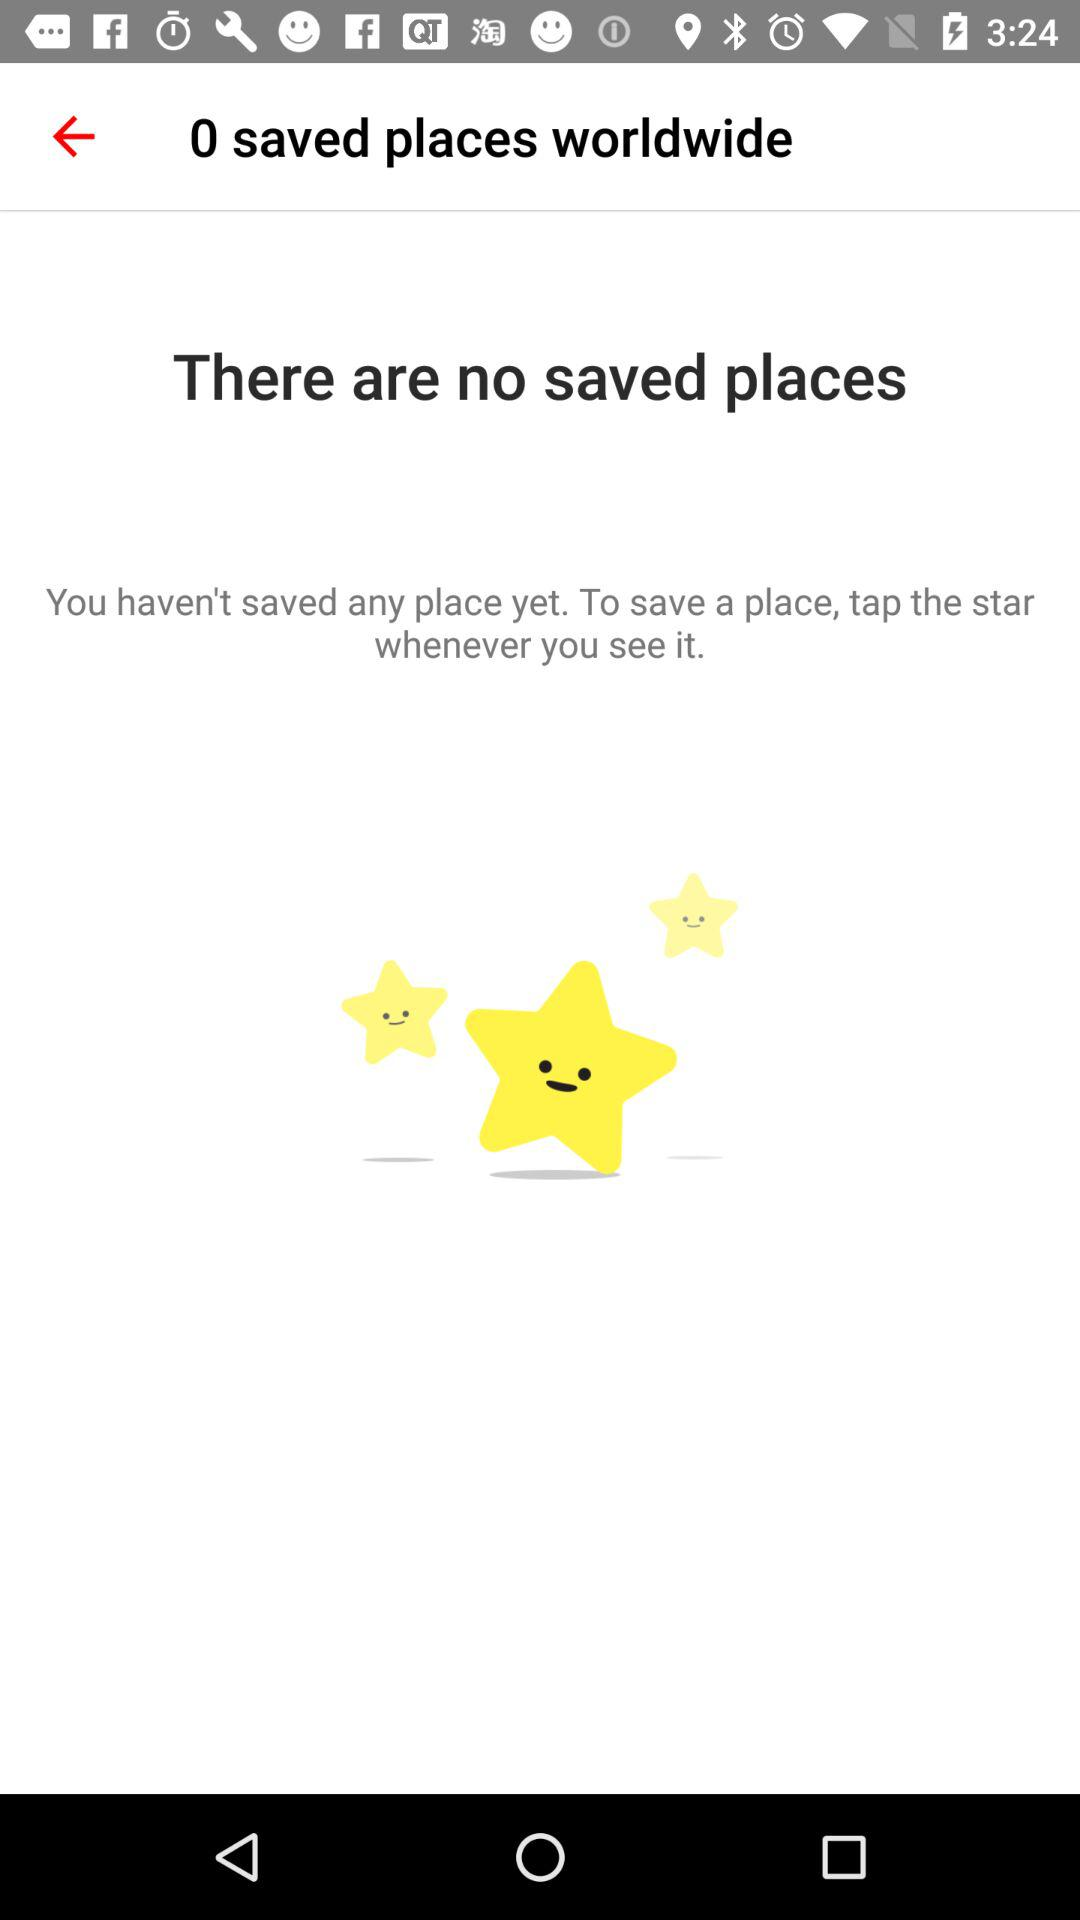How many saved places are there?
Answer the question using a single word or phrase. 0 